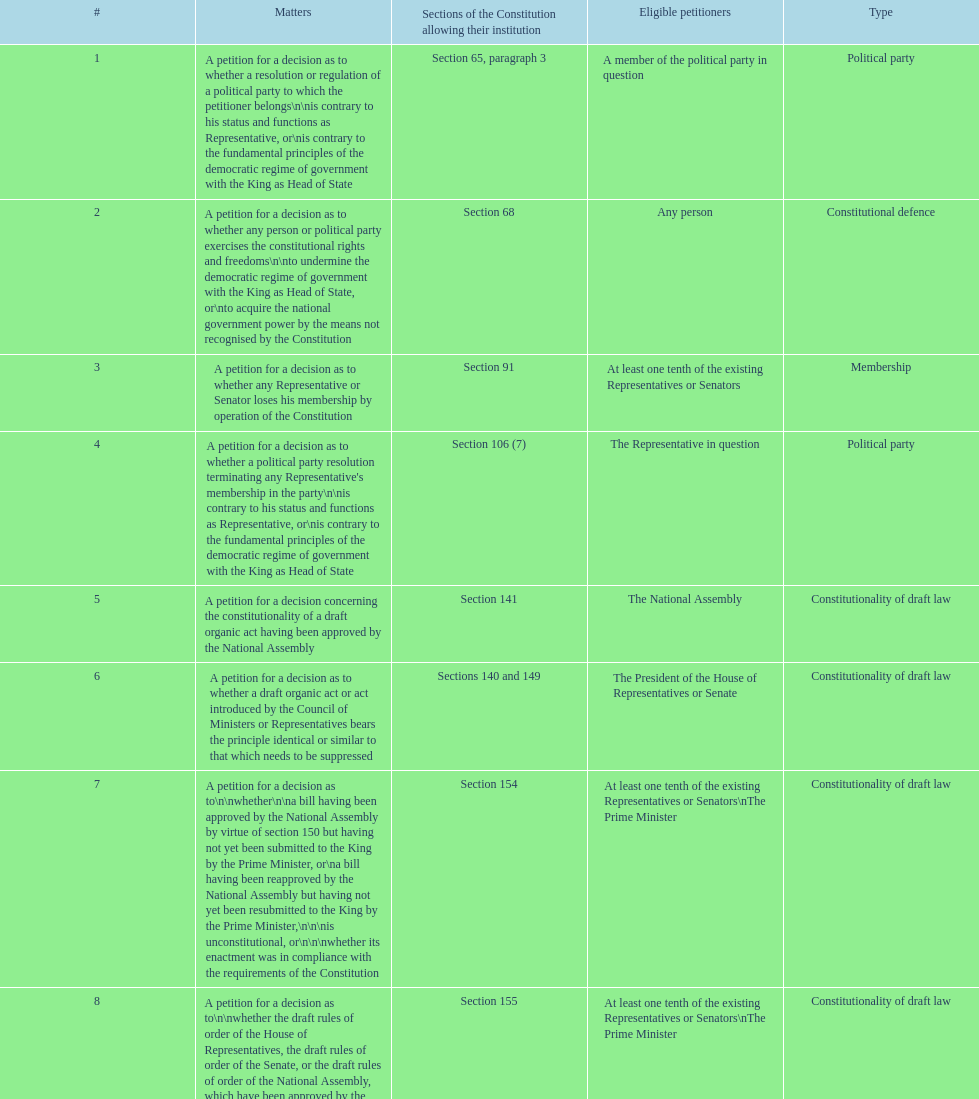How many matters require at least one tenth of the existing representatives or senators? 7. 